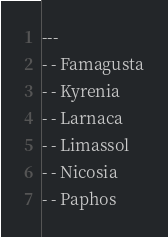Convert code to text. <code><loc_0><loc_0><loc_500><loc_500><_YAML_>---
- - Famagusta
- - Kyrenia
- - Larnaca
- - Limassol
- - Nicosia
- - Paphos
</code> 